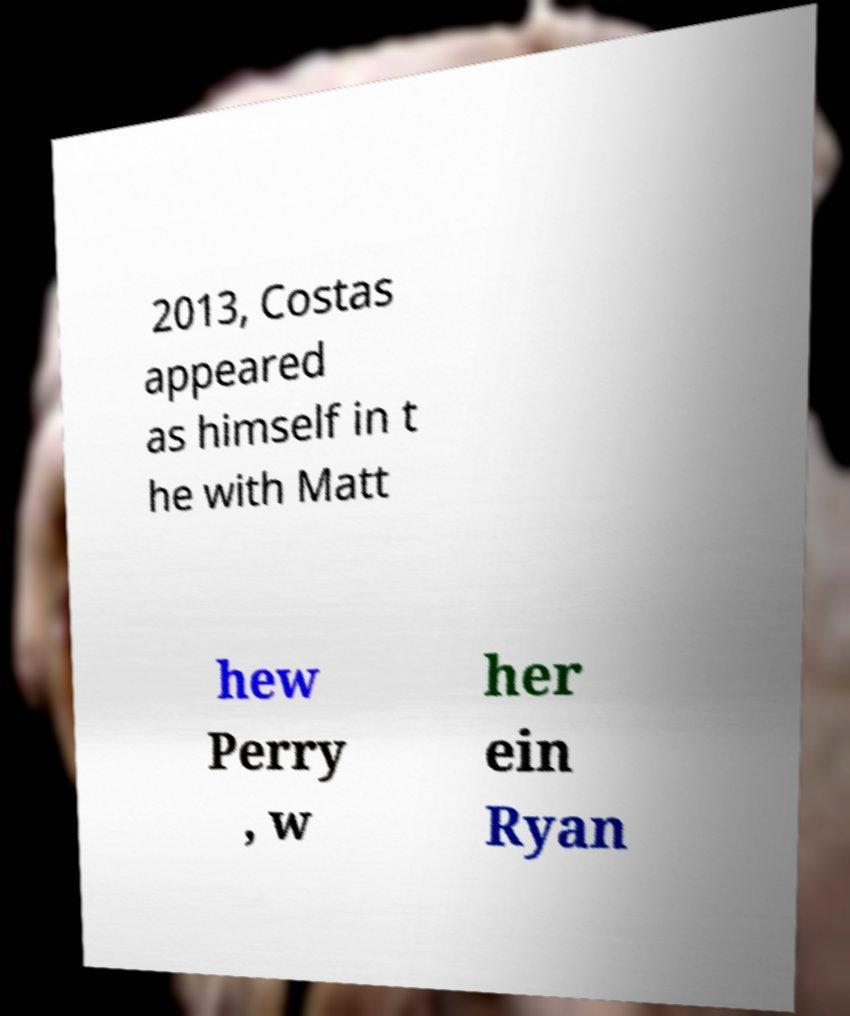Could you extract and type out the text from this image? 2013, Costas appeared as himself in t he with Matt hew Perry , w her ein Ryan 